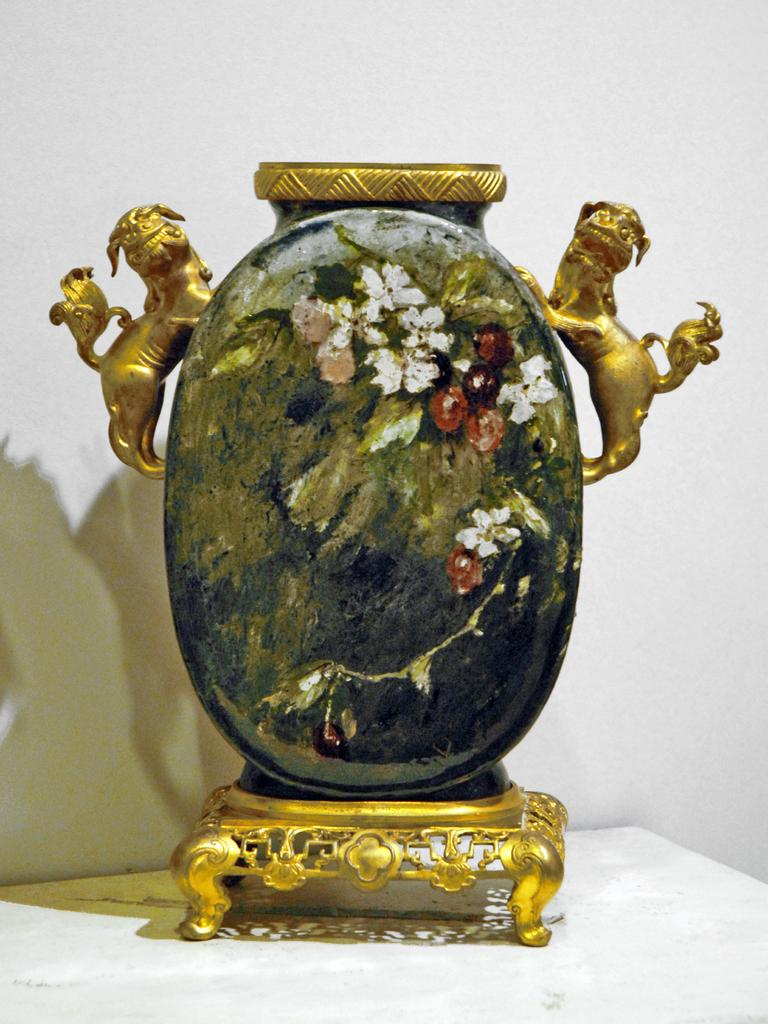What is the main subject in the center of the image? There is an object in the center of the image. What other subjects can be seen in the image? There are two statues of animals in the image. Can you describe the furniture in the image? There appears to be a table at the bottom of the image. What is the color of the background in the image? The background of the image is white. What type of soup is being served in the image? There is no soup present in the image. Can you describe the yarn used to create the animal statues? There is no yarn used to create the animal statues in the image; they are likely made of a different material. 